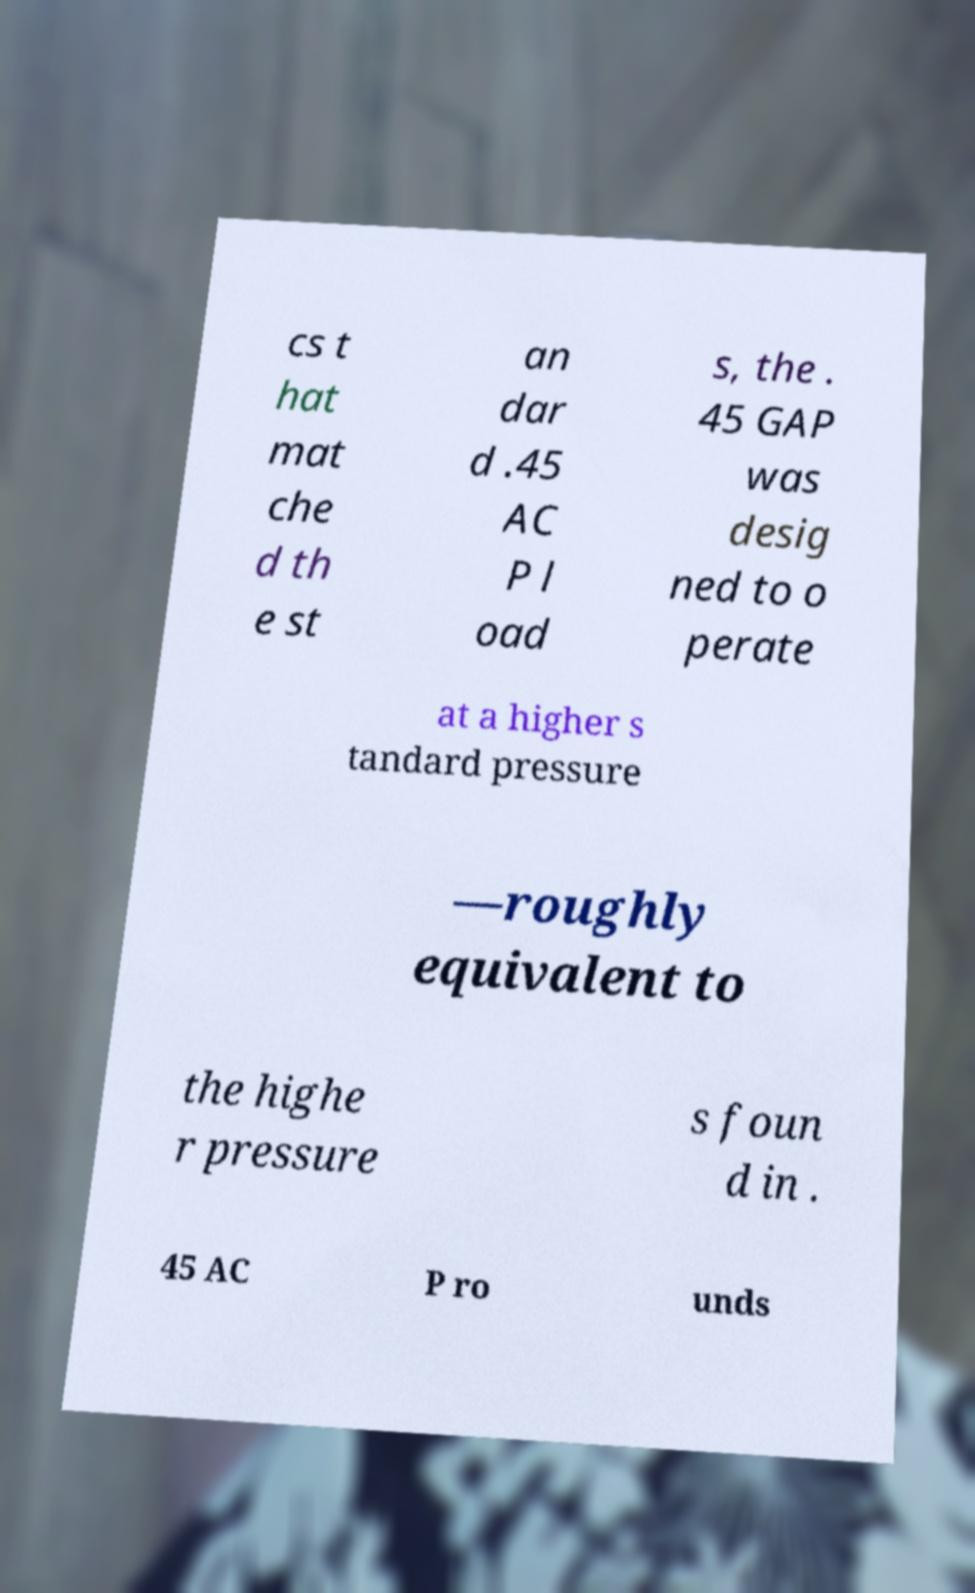Can you read and provide the text displayed in the image?This photo seems to have some interesting text. Can you extract and type it out for me? cs t hat mat che d th e st an dar d .45 AC P l oad s, the . 45 GAP was desig ned to o perate at a higher s tandard pressure —roughly equivalent to the highe r pressure s foun d in . 45 AC P ro unds 